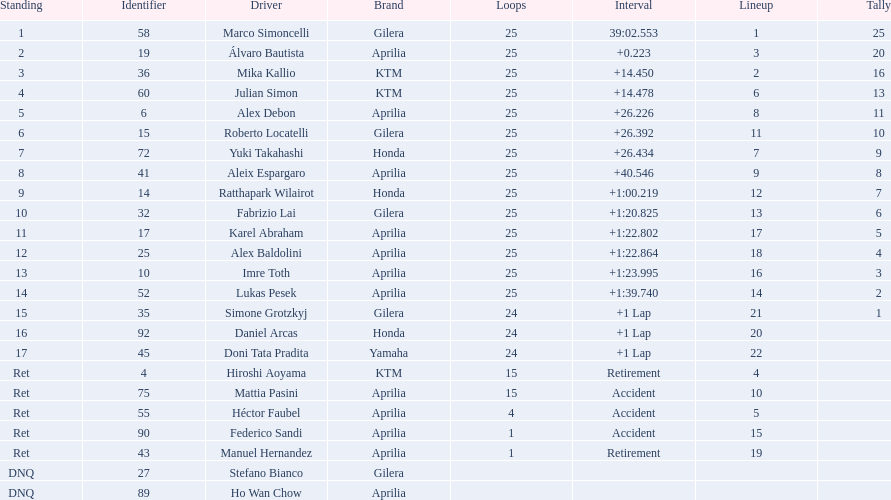Who are all the riders? Marco Simoncelli, Álvaro Bautista, Mika Kallio, Julian Simon, Alex Debon, Roberto Locatelli, Yuki Takahashi, Aleix Espargaro, Ratthapark Wilairot, Fabrizio Lai, Karel Abraham, Alex Baldolini, Imre Toth, Lukas Pesek, Simone Grotzkyj, Daniel Arcas, Doni Tata Pradita, Hiroshi Aoyama, Mattia Pasini, Héctor Faubel, Federico Sandi, Manuel Hernandez, Stefano Bianco, Ho Wan Chow. Which held rank 1? Marco Simoncelli. 